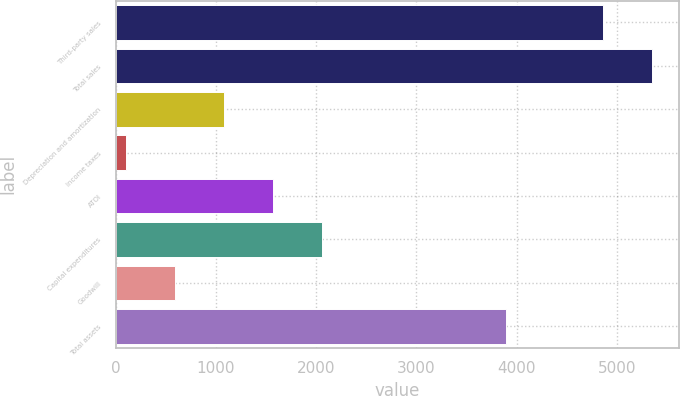Convert chart. <chart><loc_0><loc_0><loc_500><loc_500><bar_chart><fcel>Third-party sales<fcel>Total sales<fcel>Depreciation and amortization<fcel>Income taxes<fcel>ATOI<fcel>Capital expenditures<fcel>Goodwill<fcel>Total assets<nl><fcel>4864<fcel>5351.5<fcel>1082<fcel>107<fcel>1569.5<fcel>2057<fcel>594.5<fcel>3891<nl></chart> 